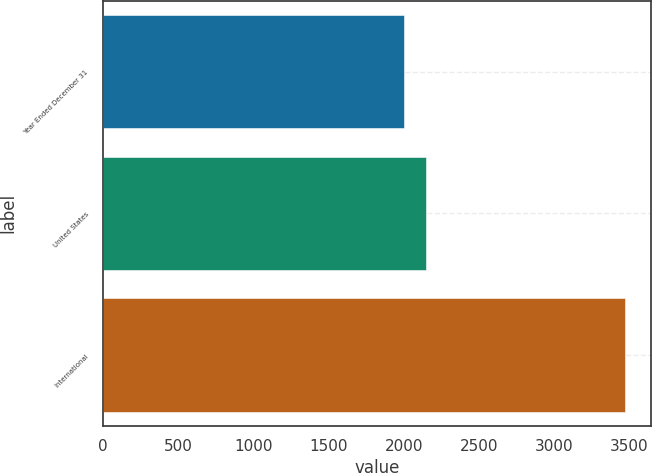<chart> <loc_0><loc_0><loc_500><loc_500><bar_chart><fcel>Year Ended December 31<fcel>United States<fcel>International<nl><fcel>2003<fcel>2149.3<fcel>3466<nl></chart> 